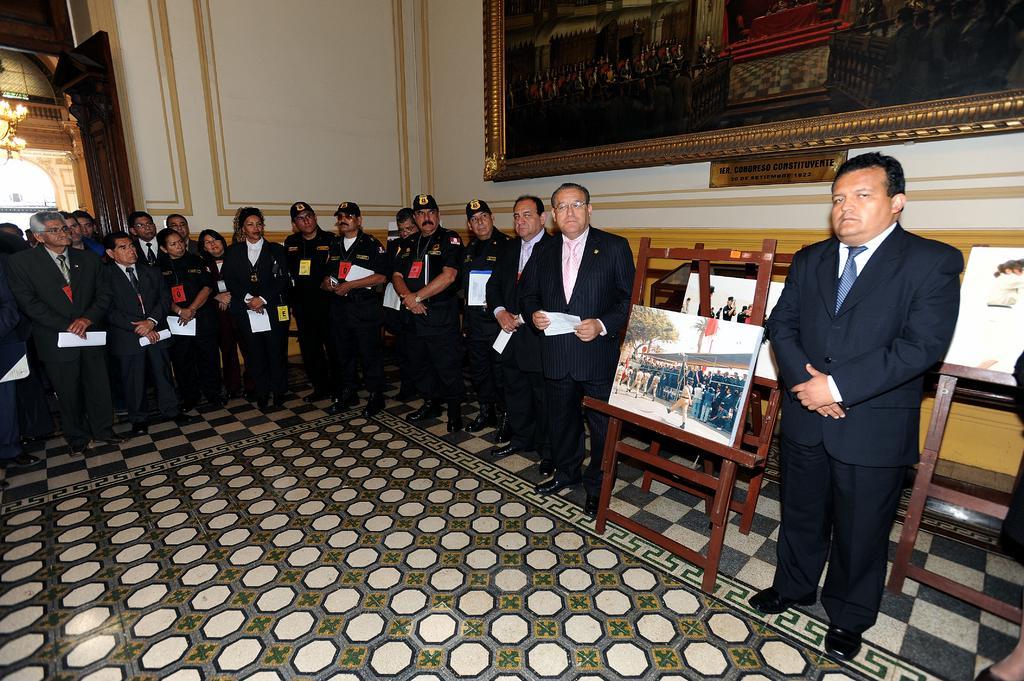In one or two sentences, can you explain what this image depicts? This image consists of many people wearing black suits and holding papers. At the bottom, there is a floor. On the right, we can see man frames. In the background, we can see the walls on which there is a big frame. 